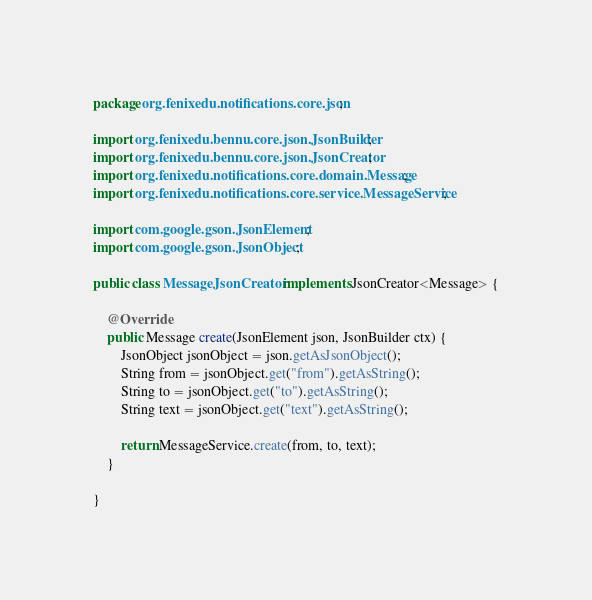Convert code to text. <code><loc_0><loc_0><loc_500><loc_500><_Java_>package org.fenixedu.notifications.core.json;

import org.fenixedu.bennu.core.json.JsonBuilder;
import org.fenixedu.bennu.core.json.JsonCreator;
import org.fenixedu.notifications.core.domain.Message;
import org.fenixedu.notifications.core.service.MessageService;

import com.google.gson.JsonElement;
import com.google.gson.JsonObject;

public class MessageJsonCreator implements JsonCreator<Message> {

    @Override
    public Message create(JsonElement json, JsonBuilder ctx) {
        JsonObject jsonObject = json.getAsJsonObject();
        String from = jsonObject.get("from").getAsString();
        String to = jsonObject.get("to").getAsString();
        String text = jsonObject.get("text").getAsString();

        return MessageService.create(from, to, text);
    }

}
</code> 